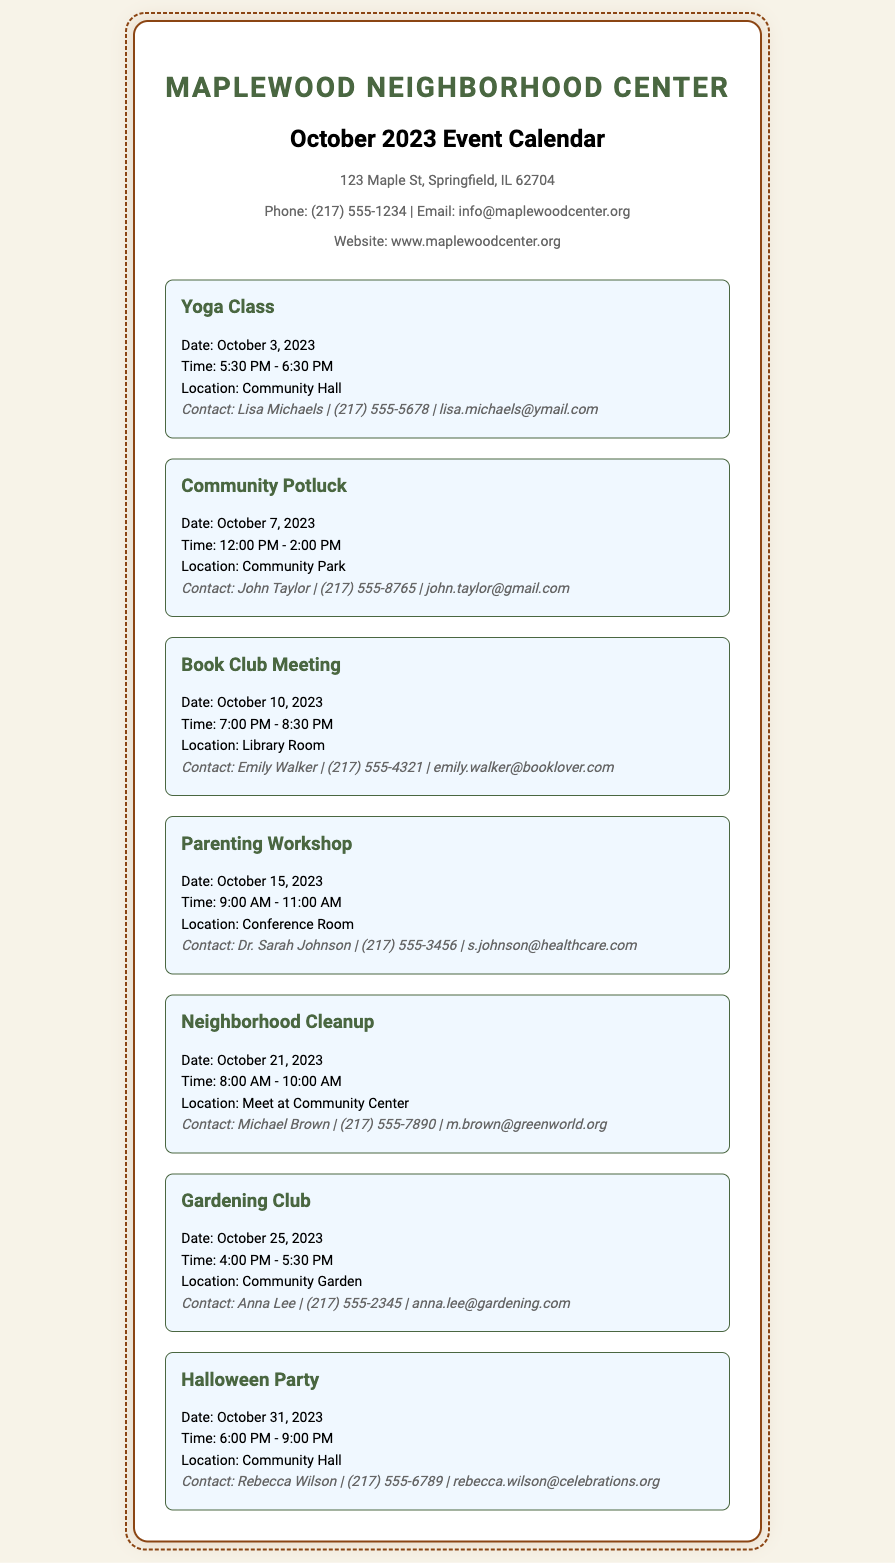What is the address of the Maplewood Neighborhood Center? The address is found in the contact information section of the document.
Answer: 123 Maple St, Springfield, IL 62704 When is the Community Potluck scheduled? The date for the Community Potluck is specifically mentioned with the event details.
Answer: October 7, 2023 Who is the contact person for the Yoga Class? The contact information for the Yoga Class is provided with the event details.
Answer: Lisa Michaels What time does the Halloween Party start? The time for the Halloween Party is included in the event details.
Answer: 6:00 PM How many events are listed in the October 2023 calendar? The number of events can be counted from the list provided in the document.
Answer: 7 Which event occurs on October 15, 2023? The event is specified by its date in the event list.
Answer: Parenting Workshop What is the location of the Neighborhood Cleanup? The location is mentioned with the specific event details.
Answer: Meet at Community Center What is the contact email for the Gardening Club? The email is provided in the contact details of the Gardening Club event.
Answer: anna.lee@gardening.com 